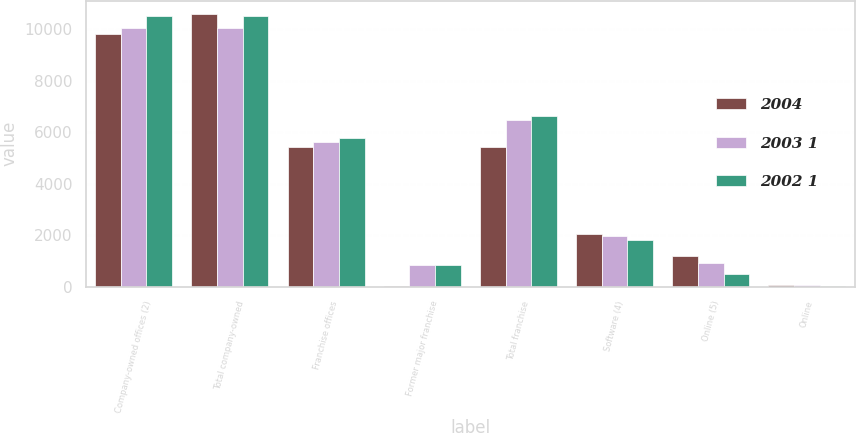Convert chart. <chart><loc_0><loc_0><loc_500><loc_500><stacked_bar_chart><ecel><fcel>Company-owned offices (2)<fcel>Total company-owned<fcel>Franchise offices<fcel>Former major franchise<fcel>Total franchise<fcel>Software (4)<fcel>Online (5)<fcel>Online<nl><fcel>2004<fcel>9811<fcel>10586<fcel>5413<fcel>16<fcel>5429<fcel>2027<fcel>1207<fcel>57<nl><fcel>2003 1<fcel>10058<fcel>10058<fcel>5629<fcel>830<fcel>6459<fcel>1963<fcel>920<fcel>75<nl><fcel>2002 1<fcel>10513<fcel>10513<fcel>5785<fcel>850<fcel>6635<fcel>1825<fcel>481<fcel>33<nl></chart> 